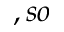Convert formula to latex. <formula><loc_0><loc_0><loc_500><loc_500>, s o</formula> 